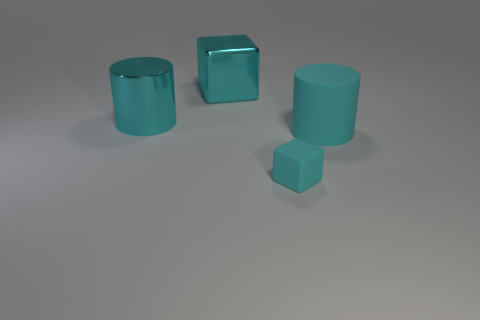Add 1 big cyan metallic blocks. How many objects exist? 5 Subtract all gray cubes. How many purple cylinders are left? 0 Subtract all red cylinders. Subtract all cyan cylinders. How many objects are left? 2 Add 3 things. How many things are left? 7 Add 2 brown shiny things. How many brown shiny things exist? 2 Subtract 0 yellow balls. How many objects are left? 4 Subtract 2 cylinders. How many cylinders are left? 0 Subtract all red cylinders. Subtract all yellow balls. How many cylinders are left? 2 